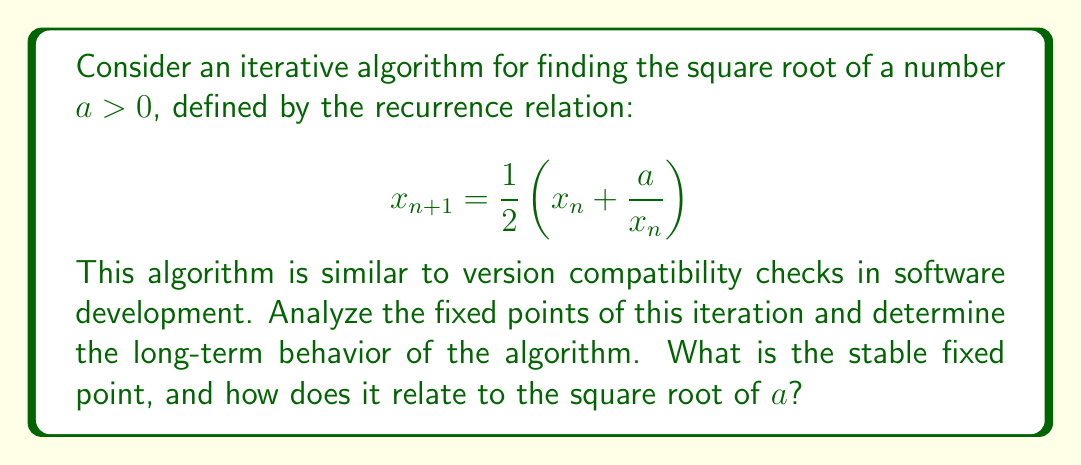Provide a solution to this math problem. 1. First, let's find the fixed points of the iteration. A fixed point $x^*$ satisfies:

   $$x^* = \frac{1}{2}\left(x^* + \frac{a}{x^*}\right)$$

2. Multiply both sides by $2x^*$:

   $$2(x^*)^2 = (x^*)^2 + a$$

3. Simplify:

   $$(x^*)^2 = a$$

4. Solve for $x^*$:

   $$x^* = \pm\sqrt{a}$$

   Since we're dealing with $a > 0$, we only consider the positive root.

5. To determine the stability of the fixed point, we analyze the derivative of the iteration function at the fixed point:

   $$f(x) = \frac{1}{2}\left(x + \frac{a}{x}\right)$$
   $$f'(x) = \frac{1}{2}\left(1 - \frac{a}{x^2}\right)$$

6. Evaluate $f'(x^*)$ at the fixed point $x^* = \sqrt{a}$:

   $$f'(\sqrt{a}) = \frac{1}{2}\left(1 - \frac{a}{(\sqrt{a})^2}\right) = \frac{1}{2}(1 - 1) = 0$$

7. Since $|f'(\sqrt{a})| = 0 < 1$, the fixed point $\sqrt{a}$ is stable.

8. This means that for any initial value $x_0 > 0$, the iteration will converge to $\sqrt{a}$.

The stability of this fixed point is analogous to how compatible software versions tend to converge to a stable state over time, ensuring long-term compatibility and functionality.
Answer: The stable fixed point is $\sqrt{a}$. 